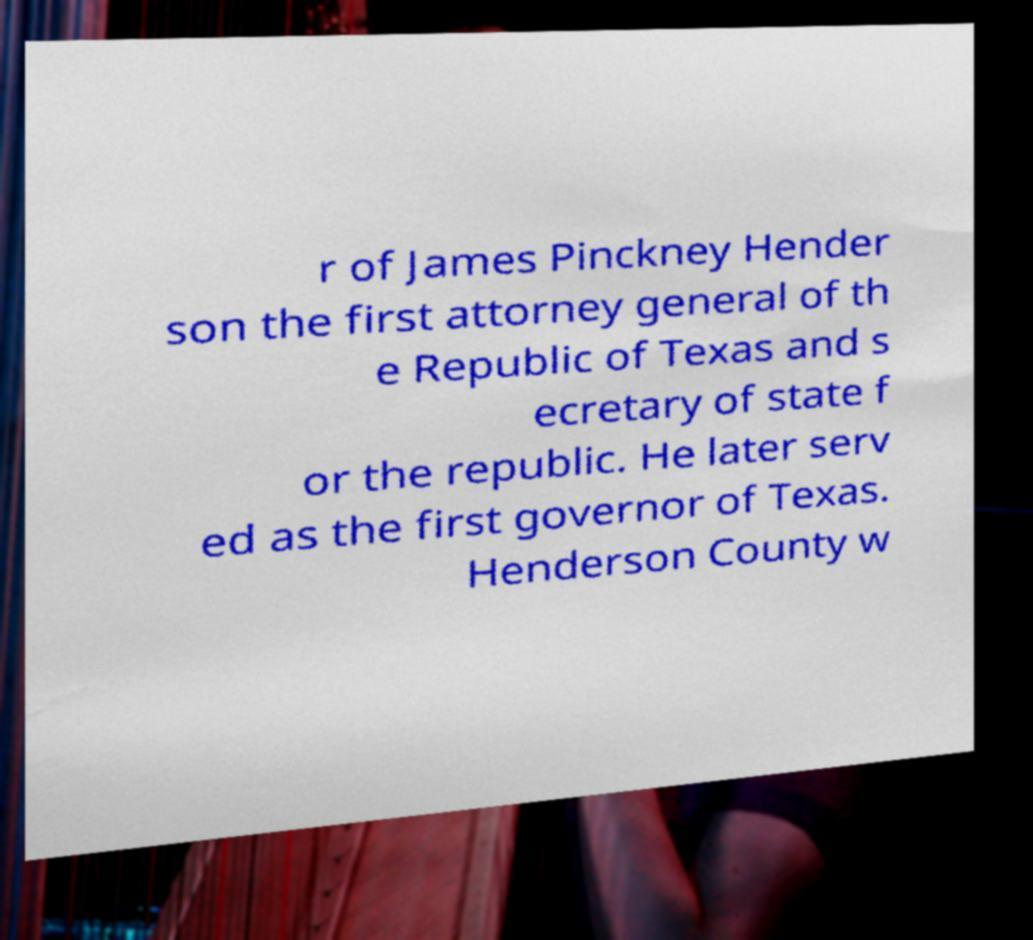There's text embedded in this image that I need extracted. Can you transcribe it verbatim? r of James Pinckney Hender son the first attorney general of th e Republic of Texas and s ecretary of state f or the republic. He later serv ed as the first governor of Texas. Henderson County w 